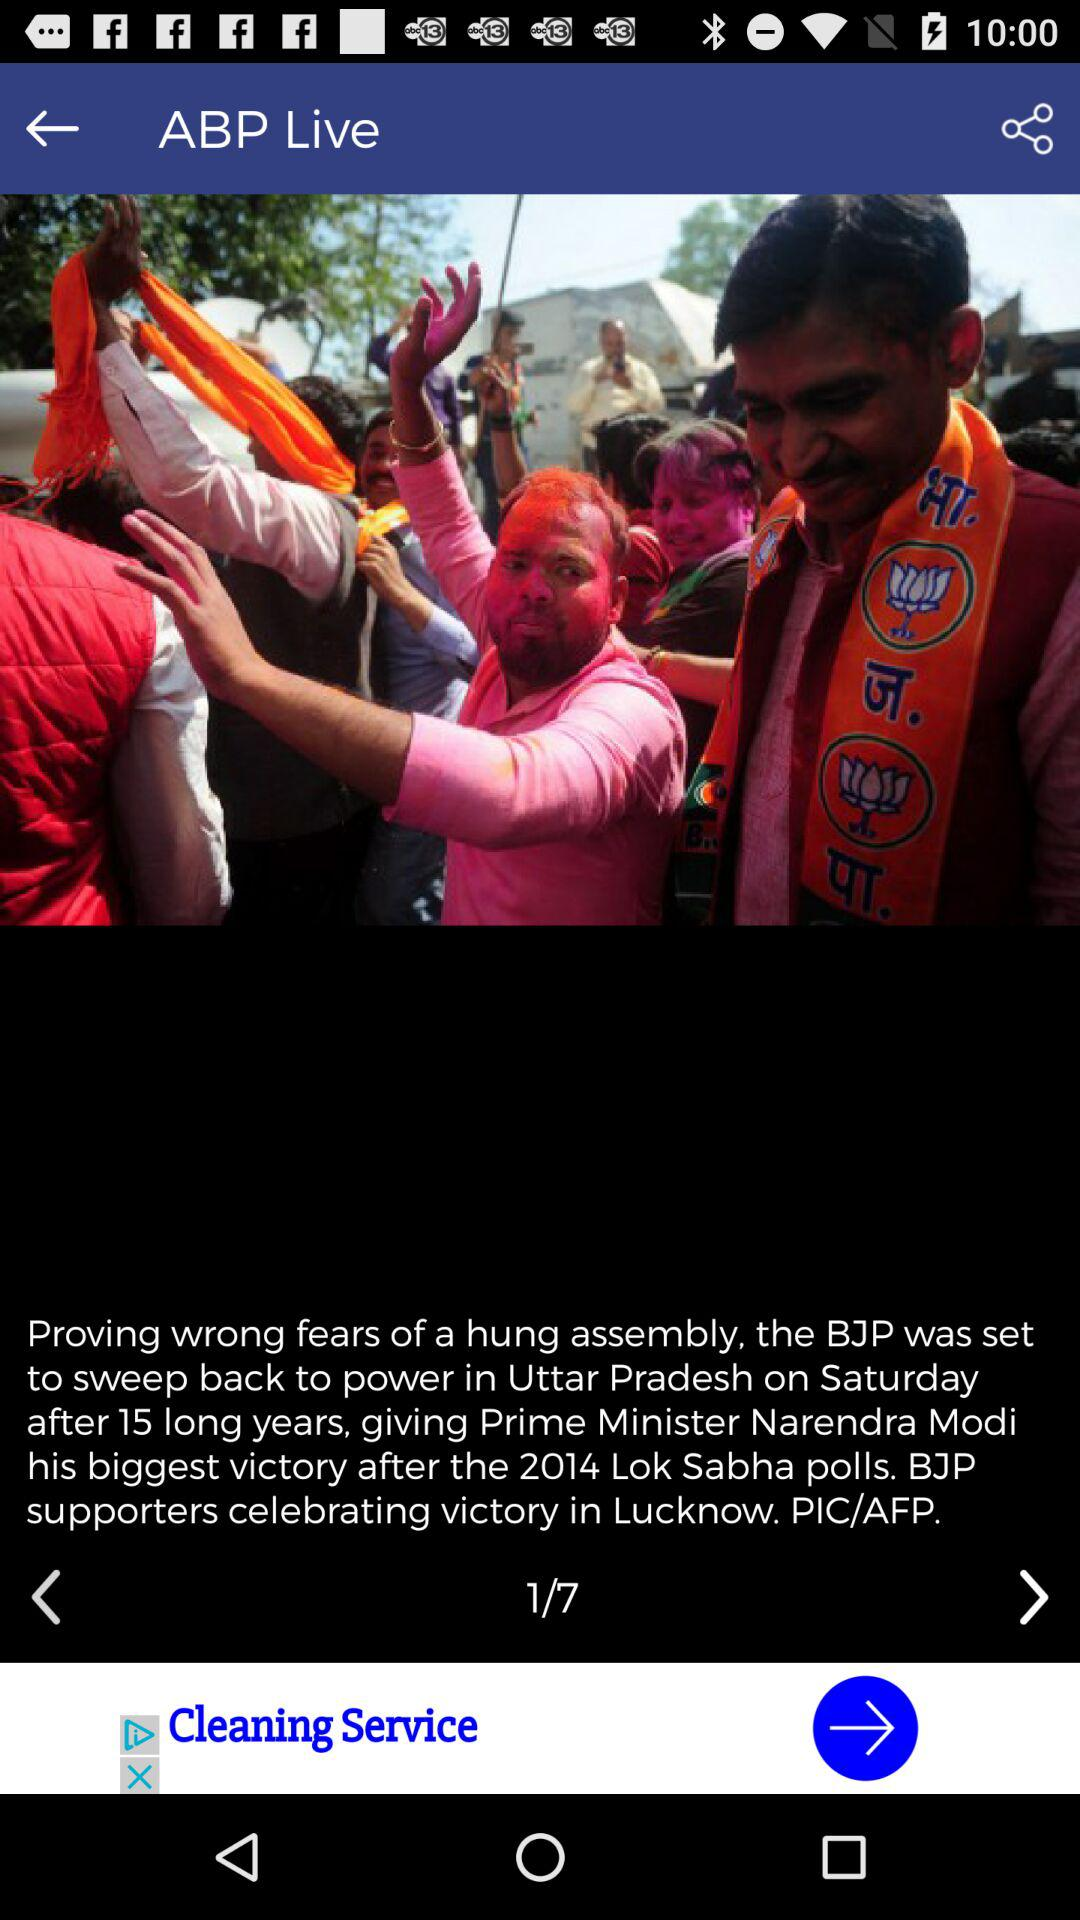What is the total count of news? The total count of news is 7. 